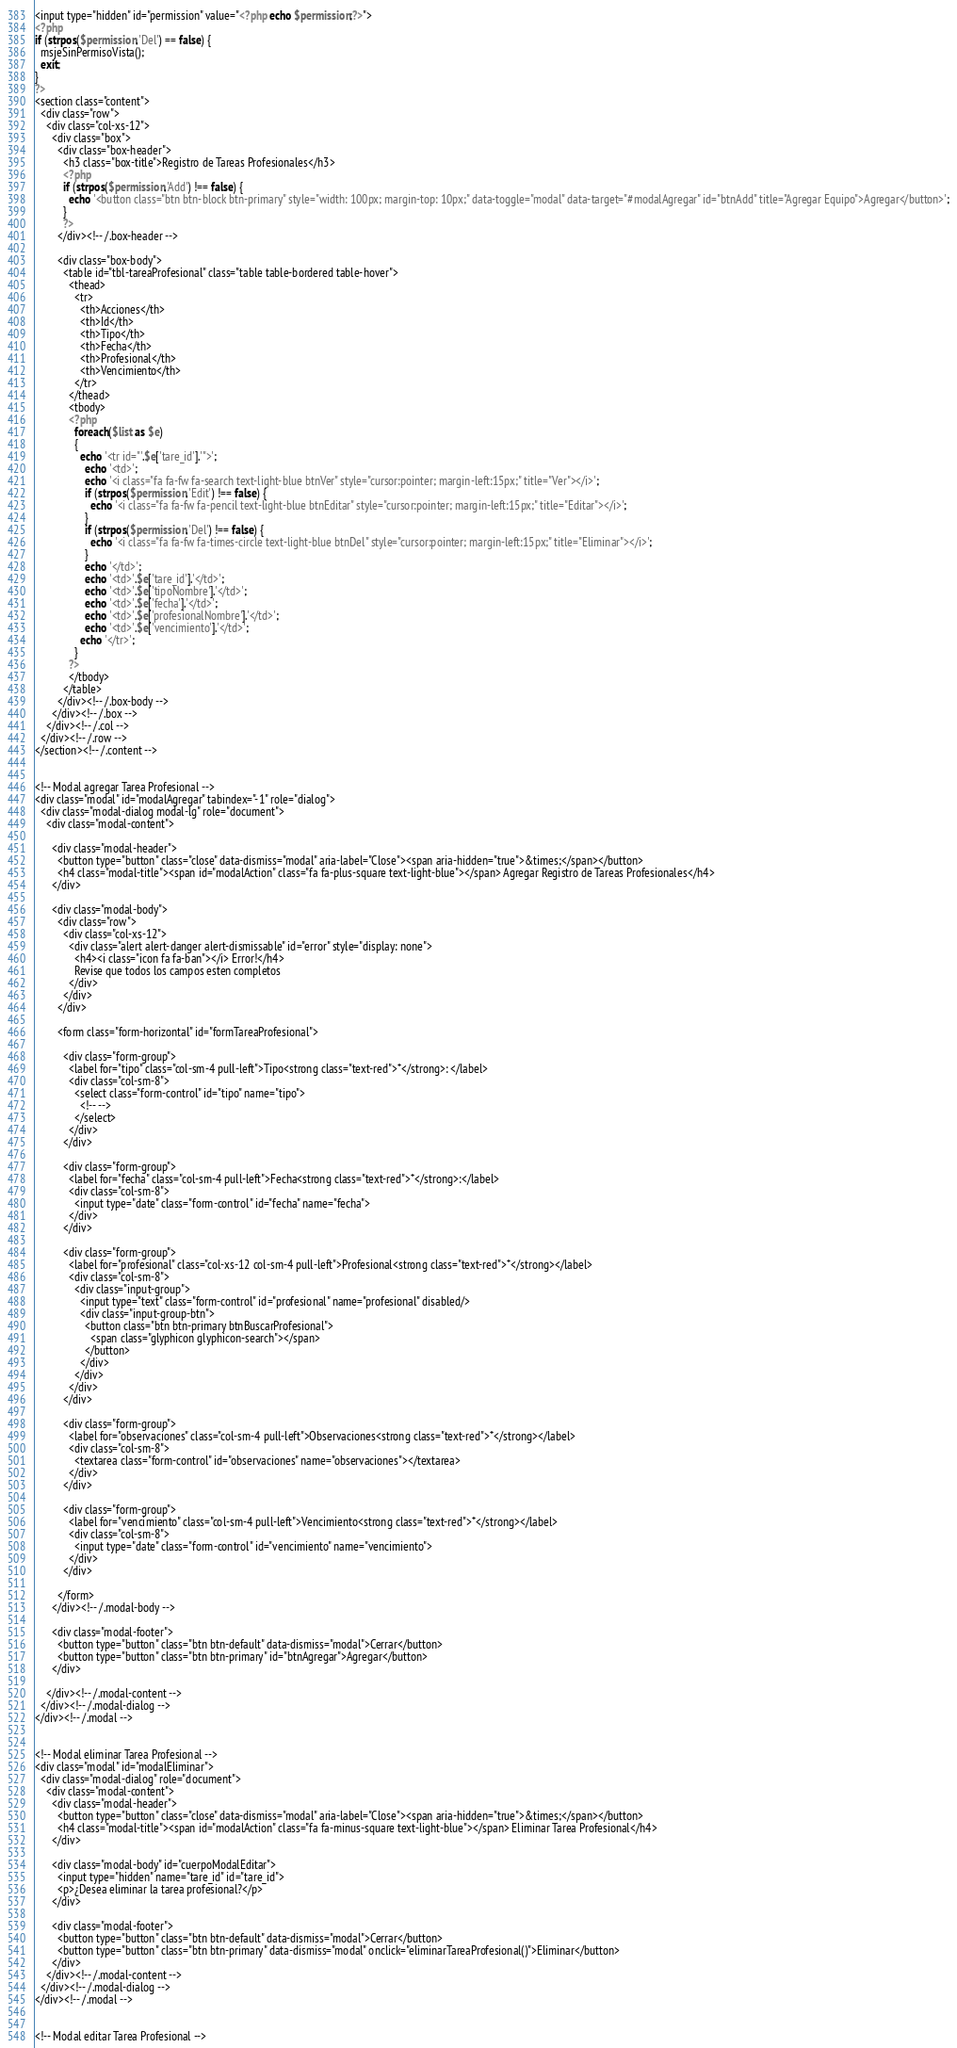<code> <loc_0><loc_0><loc_500><loc_500><_PHP_><input type="hidden" id="permission" value="<?php echo $permission;?>">
<?php
if (strpos($permission,'Del') == false) {
  msjeSinPermisoVista();
  exit;
}
?>
<section class="content">
  <div class="row">
    <div class="col-xs-12">
      <div class="box">
        <div class="box-header">
          <h3 class="box-title">Registro de Tareas Profesionales</h3>
          <?php
          if (strpos($permission,'Add') !== false) {
            echo '<button class="btn btn-block btn-primary" style="width: 100px; margin-top: 10px;" data-toggle="modal" data-target="#modalAgregar" id="btnAdd" title="Agregar Equipo">Agregar</button>';
          }
          ?>
        </div><!-- /.box-header -->

        <div class="box-body">
          <table id="tbl-tareaProfesional" class="table table-bordered table-hover">
            <thead>
              <tr>
                <th>Acciones</th>
                <th>Id</th>
                <th>Tipo</th>
                <th>Fecha</th>
                <th>Profesional</th>
                <th>Vencimiento</th>
              </tr>
            </thead>
            <tbody>
            <?php
              foreach($list as $e)
              {
                echo '<tr id="'.$e['tare_id'].'">';
                  echo '<td>';
                  echo '<i class="fa fa-fw fa-search text-light-blue btnVer" style="cursor:pointer; margin-left:15px;" title="Ver"></i>';
                  if (strpos($permission,'Edit') !== false) {
                    echo '<i class="fa fa-fw fa-pencil text-light-blue btnEditar" style="cursor:pointer; margin-left:15px;" title="Editar"></i>';
                  }
                  if (strpos($permission,'Del') !== false) {
                    echo '<i class="fa fa-fw fa-times-circle text-light-blue btnDel" style="cursor:pointer; margin-left:15px;" title="Eliminar"></i>';
                  }
                  echo '</td>';
                  echo '<td>'.$e['tare_id'].'</td>';
                  echo '<td>'.$e['tipoNombre'].'</td>';
                  echo '<td>'.$e['fecha'].'</td>';
                  echo '<td>'.$e['profesionalNombre'].'</td>';
                  echo '<td>'.$e['vencimiento'].'</td>';
                echo '</tr>';
              }
            ?>
            </tbody>
          </table>
        </div><!-- /.box-body -->
      </div><!-- /.box -->
    </div><!-- /.col -->
  </div><!-- /.row -->
</section><!-- /.content -->


<!-- Modal agregar Tarea Profesional -->
<div class="modal" id="modalAgregar" tabindex="-1" role="dialog">
  <div class="modal-dialog modal-lg" role="document">
    <div class="modal-content">

      <div class="modal-header">
        <button type="button" class="close" data-dismiss="modal" aria-label="Close"><span aria-hidden="true">&times;</span></button>
        <h4 class="modal-title"><span id="modalAction" class="fa fa-plus-square text-light-blue"></span> Agregar Registro de Tareas Profesionales</h4>
      </div>

      <div class="modal-body">
        <div class="row">
          <div class="col-xs-12">
            <div class="alert alert-danger alert-dismissable" id="error" style="display: none">
              <h4><i class="icon fa fa-ban"></i> Error!</h4>
              Revise que todos los campos esten completos
            </div>
          </div>
        </div>

        <form class="form-horizontal" id="formTareaProfesional">
          
          <div class="form-group">
            <label for="tipo" class="col-sm-4 pull-left">Tipo<strong class="text-red">*</strong>: </label>
            <div class="col-sm-8">
              <select class="form-control" id="tipo" name="tipo">
                <!-- -->
              </select>
            </div>
          </div>

          <div class="form-group">
            <label for="fecha" class="col-sm-4 pull-left">Fecha<strong class="text-red">*</strong>:</label>
            <div class="col-sm-8">
              <input type="date" class="form-control" id="fecha" name="fecha">
            </div>
          </div>

          <div class="form-group">
            <label for="profesional" class="col-xs-12 col-sm-4 pull-left">Profesional<strong class="text-red">*</strong></label>
            <div class="col-sm-8">
              <div class="input-group">
                <input type="text" class="form-control" id="profesional" name="profesional" disabled/>
                <div class="input-group-btn">
                  <button class="btn btn-primary btnBuscarProfesional">
                    <span class="glyphicon glyphicon-search"></span>
                  </button>
                </div>
              </div>
            </div>
          </div>

          <div class="form-group">
            <label for="observaciones" class="col-sm-4 pull-left">Observaciones<strong class="text-red">*</strong></label>
            <div class="col-sm-8">
              <textarea class="form-control" id="observaciones" name="observaciones"></textarea>
            </div>
          </div>

          <div class="form-group">
            <label for="vencimiento" class="col-sm-4 pull-left">Vencimiento<strong class="text-red">*</strong></label>
            <div class="col-sm-8">
              <input type="date" class="form-control" id="vencimiento" name="vencimiento">
            </div>
          </div>

        </form>
      </div><!-- /.modal-body -->

      <div class="modal-footer">
        <button type="button" class="btn btn-default" data-dismiss="modal">Cerrar</button>
        <button type="button" class="btn btn-primary" id="btnAgregar">Agregar</button>
      </div>

    </div><!-- /.modal-content -->
  </div><!-- /.modal-dialog -->
</div><!-- /.modal -->


<!-- Modal eliminar Tarea Profesional -->
<div class="modal" id="modalEliminar">
  <div class="modal-dialog" role="document">
    <div class="modal-content">
      <div class="modal-header">
        <button type="button" class="close" data-dismiss="modal" aria-label="Close"><span aria-hidden="true">&times;</span></button>
        <h4 class="modal-title"><span id="modalAction" class="fa fa-minus-square text-light-blue"></span> Eliminar Tarea Profesional</h4>
      </div>

      <div class="modal-body" id="cuerpoModalEditar">
        <input type="hidden" name="tare_id" id="tare_id">
        <p>¿Desea eliminar la tarea profesional?</p> 
      </div>

      <div class="modal-footer">
        <button type="button" class="btn btn-default" data-dismiss="modal">Cerrar</button>
        <button type="button" class="btn btn-primary" data-dismiss="modal" onclick="eliminarTareaProfesional()">Eliminar</button>
      </div>
    </div><!-- /.modal-content -->
  </div><!-- /.modal-dialog -->
</div><!-- /.modal -->


<!-- Modal editar Tarea Profesional --></code> 